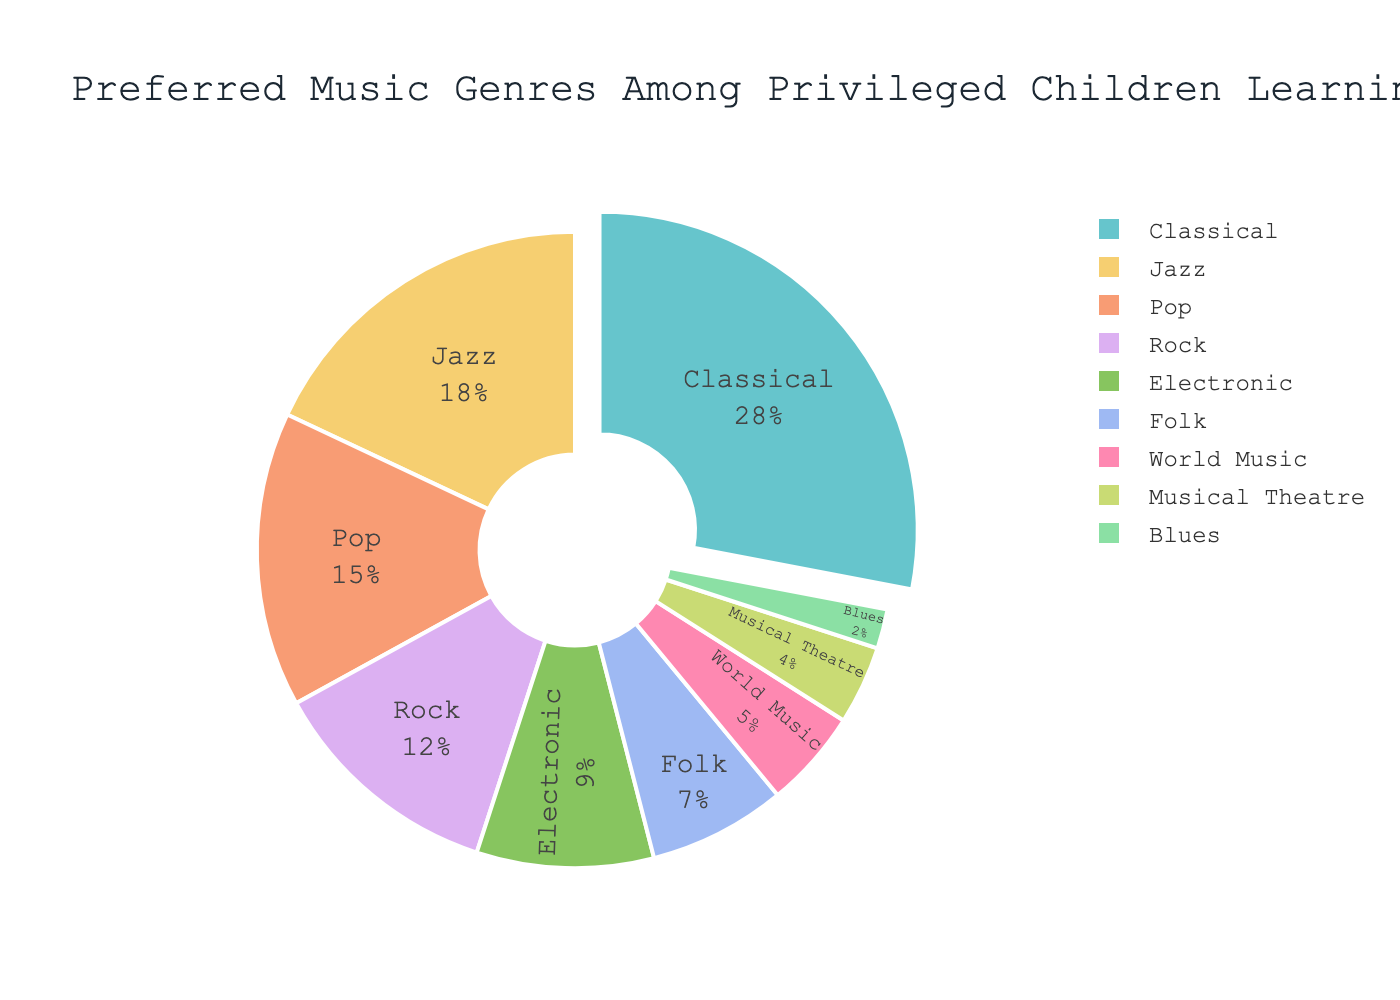What is the most popular music genre among privileged children learning multiple instruments? The most popular genre is determined by the largest segment in the pie chart. Classical music has the largest percentage at 28%.
Answer: Classical Which music genre has a smaller percentage, Jazz or Pop? Compare the percentages of Jazz and Pop from the pie chart. Jazz is 18%, and Pop is 15%. Pop has the smaller percentage.
Answer: Pop How much more popular is Rock compared to Electronic music? Rock has a percentage of 12%, and Electronic has 9%. Subtract 9 from 12 to find the difference between Rock and Electronic music.
Answer: 3% What are the combined percentages of Folk and World Music? Add the percentages of Folk and World Music. Folk has 7%, and World Music has 5%. Summing these gives 7 + 5 = 12%.
Answer: 12% Which music genre is represented by the least percentage, and what is that percentage? The smallest segment in the pie chart represents Blues with a percentage of 2%.
Answer: Blues, 2% Among Classical, Jazz, and Pop, which genre is in the middle in terms of percentage? Compare the percentages of Classical (28%), Jazz (18%), and Pop (15%). Jazz is in the middle.
Answer: Jazz What is the total percentage of the top three genres combined? Sum the percentages of the top three genres: Classical (28%), Jazz (18%), and Pop (15%). The total is 28 + 18 + 15 = 61%.
Answer: 61% Of the genres with single-digit percentages, which one has the highest percentage, and what is that percentage? Compare the single-digit percentages: Electronic (9%), Folk (7%), World Music (5%), Musical Theatre (4%), Blues (2%). Electronic has the highest at 9%.
Answer: Electronic, 9% Is the percentage of Jazz closer to that of Classical or Pop? Compare the differences: Jazz to Classical is 28 - 18 = 10; Jazz to Pop is 18 - 15 = 3. Jazz is closer to Pop.
Answer: Pop What is the difference in percentage points between the sum of Electronic, World Music, and Musical Theatre compared to Rock? Sum the percentages of Electronic, World Music, and Musical Theatre: 9 + 5 + 4 = 18%. Rock is 12%. The difference is 18 - 12 = 6%.
Answer: 6% 